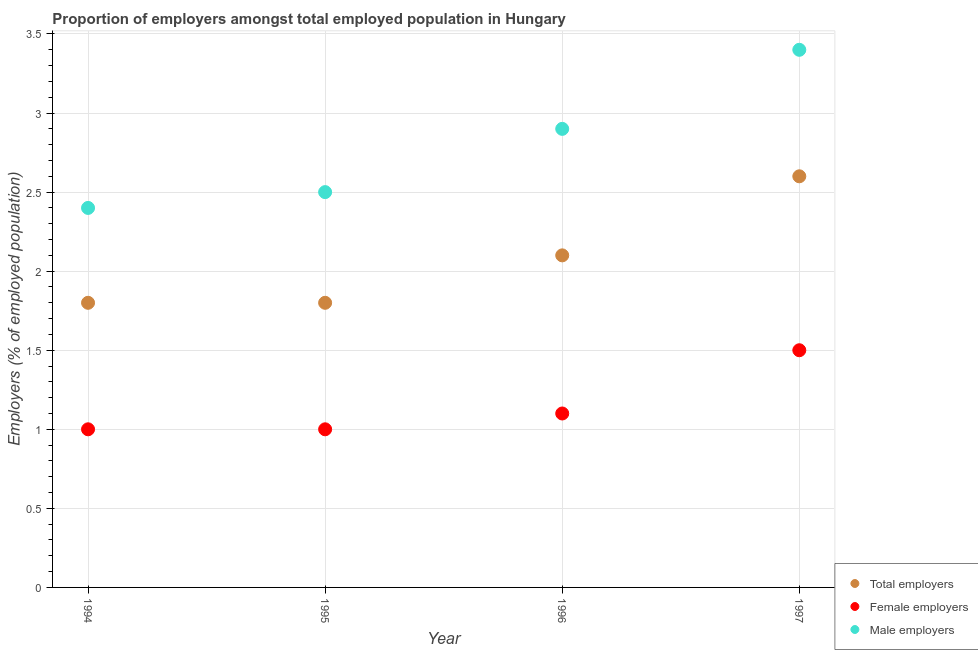What is the percentage of female employers in 1996?
Offer a very short reply. 1.1. Across all years, what is the maximum percentage of male employers?
Provide a succinct answer. 3.4. Across all years, what is the minimum percentage of female employers?
Keep it short and to the point. 1. In which year was the percentage of male employers maximum?
Offer a terse response. 1997. In which year was the percentage of male employers minimum?
Your answer should be compact. 1994. What is the total percentage of female employers in the graph?
Ensure brevity in your answer.  4.6. What is the difference between the percentage of male employers in 1997 and the percentage of total employers in 1996?
Keep it short and to the point. 1.3. What is the average percentage of male employers per year?
Your answer should be very brief. 2.8. In the year 1994, what is the difference between the percentage of female employers and percentage of total employers?
Offer a very short reply. -0.8. In how many years, is the percentage of female employers greater than 2.4 %?
Keep it short and to the point. 0. What is the ratio of the percentage of male employers in 1995 to that in 1996?
Your response must be concise. 0.86. Is the percentage of total employers in 1994 less than that in 1995?
Your answer should be very brief. No. Is the difference between the percentage of total employers in 1994 and 1997 greater than the difference between the percentage of male employers in 1994 and 1997?
Offer a very short reply. Yes. What is the difference between the highest and the second highest percentage of male employers?
Offer a terse response. 0.5. What is the difference between the highest and the lowest percentage of female employers?
Make the answer very short. 0.5. In how many years, is the percentage of male employers greater than the average percentage of male employers taken over all years?
Offer a terse response. 2. Is it the case that in every year, the sum of the percentage of total employers and percentage of female employers is greater than the percentage of male employers?
Give a very brief answer. Yes. Does the percentage of total employers monotonically increase over the years?
Give a very brief answer. No. Is the percentage of total employers strictly greater than the percentage of female employers over the years?
Ensure brevity in your answer.  Yes. Is the percentage of female employers strictly less than the percentage of total employers over the years?
Your response must be concise. Yes. What is the difference between two consecutive major ticks on the Y-axis?
Make the answer very short. 0.5. Where does the legend appear in the graph?
Provide a succinct answer. Bottom right. What is the title of the graph?
Make the answer very short. Proportion of employers amongst total employed population in Hungary. Does "Ages 20-60" appear as one of the legend labels in the graph?
Keep it short and to the point. No. What is the label or title of the Y-axis?
Provide a short and direct response. Employers (% of employed population). What is the Employers (% of employed population) in Total employers in 1994?
Make the answer very short. 1.8. What is the Employers (% of employed population) of Male employers in 1994?
Ensure brevity in your answer.  2.4. What is the Employers (% of employed population) of Total employers in 1995?
Offer a terse response. 1.8. What is the Employers (% of employed population) in Male employers in 1995?
Give a very brief answer. 2.5. What is the Employers (% of employed population) of Total employers in 1996?
Your answer should be compact. 2.1. What is the Employers (% of employed population) of Female employers in 1996?
Your response must be concise. 1.1. What is the Employers (% of employed population) of Male employers in 1996?
Provide a short and direct response. 2.9. What is the Employers (% of employed population) in Total employers in 1997?
Provide a short and direct response. 2.6. What is the Employers (% of employed population) in Female employers in 1997?
Your response must be concise. 1.5. What is the Employers (% of employed population) of Male employers in 1997?
Keep it short and to the point. 3.4. Across all years, what is the maximum Employers (% of employed population) of Total employers?
Offer a very short reply. 2.6. Across all years, what is the maximum Employers (% of employed population) in Female employers?
Your response must be concise. 1.5. Across all years, what is the maximum Employers (% of employed population) of Male employers?
Your answer should be compact. 3.4. Across all years, what is the minimum Employers (% of employed population) in Total employers?
Give a very brief answer. 1.8. Across all years, what is the minimum Employers (% of employed population) of Male employers?
Provide a succinct answer. 2.4. What is the total Employers (% of employed population) of Total employers in the graph?
Make the answer very short. 8.3. What is the total Employers (% of employed population) in Female employers in the graph?
Your response must be concise. 4.6. What is the difference between the Employers (% of employed population) of Male employers in 1994 and that in 1995?
Give a very brief answer. -0.1. What is the difference between the Employers (% of employed population) in Female employers in 1994 and that in 1996?
Provide a succinct answer. -0.1. What is the difference between the Employers (% of employed population) of Female employers in 1995 and that in 1996?
Offer a very short reply. -0.1. What is the difference between the Employers (% of employed population) of Total employers in 1995 and that in 1997?
Provide a short and direct response. -0.8. What is the difference between the Employers (% of employed population) of Male employers in 1995 and that in 1997?
Provide a succinct answer. -0.9. What is the difference between the Employers (% of employed population) of Total employers in 1996 and that in 1997?
Your response must be concise. -0.5. What is the difference between the Employers (% of employed population) in Female employers in 1996 and that in 1997?
Provide a succinct answer. -0.4. What is the difference between the Employers (% of employed population) in Male employers in 1996 and that in 1997?
Your answer should be very brief. -0.5. What is the difference between the Employers (% of employed population) of Total employers in 1994 and the Employers (% of employed population) of Female employers in 1995?
Provide a short and direct response. 0.8. What is the difference between the Employers (% of employed population) in Female employers in 1994 and the Employers (% of employed population) in Male employers in 1995?
Your answer should be very brief. -1.5. What is the difference between the Employers (% of employed population) in Female employers in 1994 and the Employers (% of employed population) in Male employers in 1996?
Make the answer very short. -1.9. What is the difference between the Employers (% of employed population) of Total employers in 1994 and the Employers (% of employed population) of Female employers in 1997?
Offer a very short reply. 0.3. What is the difference between the Employers (% of employed population) of Total employers in 1994 and the Employers (% of employed population) of Male employers in 1997?
Make the answer very short. -1.6. What is the difference between the Employers (% of employed population) in Female employers in 1994 and the Employers (% of employed population) in Male employers in 1997?
Your answer should be compact. -2.4. What is the difference between the Employers (% of employed population) in Total employers in 1995 and the Employers (% of employed population) in Male employers in 1996?
Offer a very short reply. -1.1. What is the difference between the Employers (% of employed population) of Total employers in 1996 and the Employers (% of employed population) of Female employers in 1997?
Your answer should be very brief. 0.6. What is the difference between the Employers (% of employed population) in Total employers in 1996 and the Employers (% of employed population) in Male employers in 1997?
Ensure brevity in your answer.  -1.3. What is the difference between the Employers (% of employed population) in Female employers in 1996 and the Employers (% of employed population) in Male employers in 1997?
Your answer should be very brief. -2.3. What is the average Employers (% of employed population) in Total employers per year?
Offer a very short reply. 2.08. What is the average Employers (% of employed population) in Female employers per year?
Your response must be concise. 1.15. What is the average Employers (% of employed population) in Male employers per year?
Make the answer very short. 2.8. In the year 1994, what is the difference between the Employers (% of employed population) of Total employers and Employers (% of employed population) of Female employers?
Offer a terse response. 0.8. In the year 1994, what is the difference between the Employers (% of employed population) in Female employers and Employers (% of employed population) in Male employers?
Offer a terse response. -1.4. In the year 1995, what is the difference between the Employers (% of employed population) in Total employers and Employers (% of employed population) in Female employers?
Provide a succinct answer. 0.8. In the year 1995, what is the difference between the Employers (% of employed population) of Total employers and Employers (% of employed population) of Male employers?
Keep it short and to the point. -0.7. In the year 1996, what is the difference between the Employers (% of employed population) in Total employers and Employers (% of employed population) in Female employers?
Provide a succinct answer. 1. In the year 1996, what is the difference between the Employers (% of employed population) of Female employers and Employers (% of employed population) of Male employers?
Offer a terse response. -1.8. In the year 1997, what is the difference between the Employers (% of employed population) in Total employers and Employers (% of employed population) in Male employers?
Provide a succinct answer. -0.8. In the year 1997, what is the difference between the Employers (% of employed population) of Female employers and Employers (% of employed population) of Male employers?
Ensure brevity in your answer.  -1.9. What is the ratio of the Employers (% of employed population) in Total employers in 1994 to that in 1995?
Offer a terse response. 1. What is the ratio of the Employers (% of employed population) of Female employers in 1994 to that in 1995?
Offer a very short reply. 1. What is the ratio of the Employers (% of employed population) in Male employers in 1994 to that in 1995?
Ensure brevity in your answer.  0.96. What is the ratio of the Employers (% of employed population) of Female employers in 1994 to that in 1996?
Offer a very short reply. 0.91. What is the ratio of the Employers (% of employed population) of Male employers in 1994 to that in 1996?
Give a very brief answer. 0.83. What is the ratio of the Employers (% of employed population) in Total employers in 1994 to that in 1997?
Offer a terse response. 0.69. What is the ratio of the Employers (% of employed population) of Male employers in 1994 to that in 1997?
Your response must be concise. 0.71. What is the ratio of the Employers (% of employed population) of Total employers in 1995 to that in 1996?
Keep it short and to the point. 0.86. What is the ratio of the Employers (% of employed population) in Female employers in 1995 to that in 1996?
Your answer should be compact. 0.91. What is the ratio of the Employers (% of employed population) in Male employers in 1995 to that in 1996?
Keep it short and to the point. 0.86. What is the ratio of the Employers (% of employed population) of Total employers in 1995 to that in 1997?
Provide a short and direct response. 0.69. What is the ratio of the Employers (% of employed population) in Male employers in 1995 to that in 1997?
Your answer should be compact. 0.74. What is the ratio of the Employers (% of employed population) of Total employers in 1996 to that in 1997?
Your response must be concise. 0.81. What is the ratio of the Employers (% of employed population) in Female employers in 1996 to that in 1997?
Your answer should be compact. 0.73. What is the ratio of the Employers (% of employed population) in Male employers in 1996 to that in 1997?
Keep it short and to the point. 0.85. 